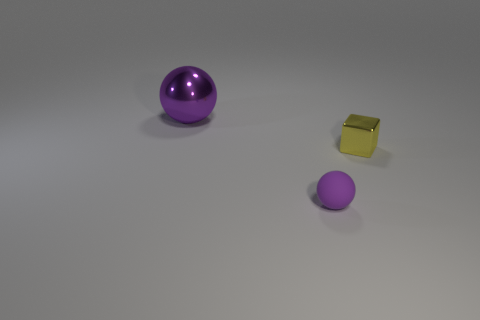Add 2 metallic blocks. How many objects exist? 5 Subtract all blocks. How many objects are left? 2 Subtract 0 red cubes. How many objects are left? 3 Subtract all purple metal things. Subtract all tiny shiny blocks. How many objects are left? 1 Add 1 small yellow things. How many small yellow things are left? 2 Add 3 cyan matte objects. How many cyan matte objects exist? 3 